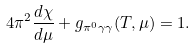<formula> <loc_0><loc_0><loc_500><loc_500>4 \pi ^ { 2 } \frac { d \chi } { d \mu } + g _ { \pi ^ { 0 } \gamma \gamma } ( T , \mu ) = 1 .</formula> 